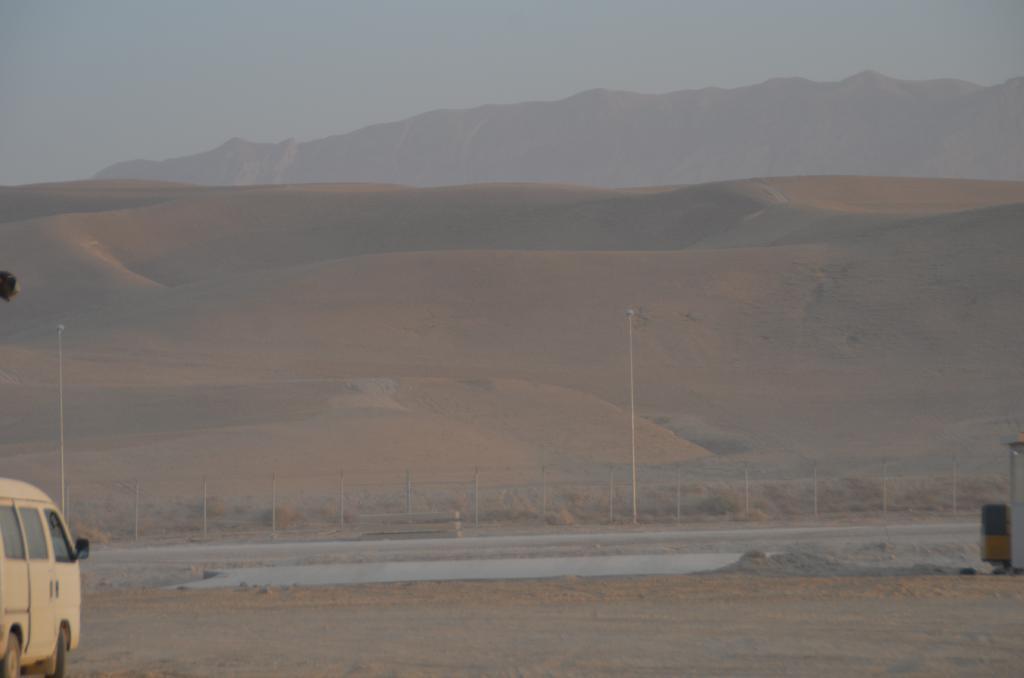Could you give a brief overview of what you see in this image? In this picture we can see ground, poles and hills. In the background of the image we can see the sky. On the right side of the image we can see objects. On the left side of the image we can see a vehicle and an object. 